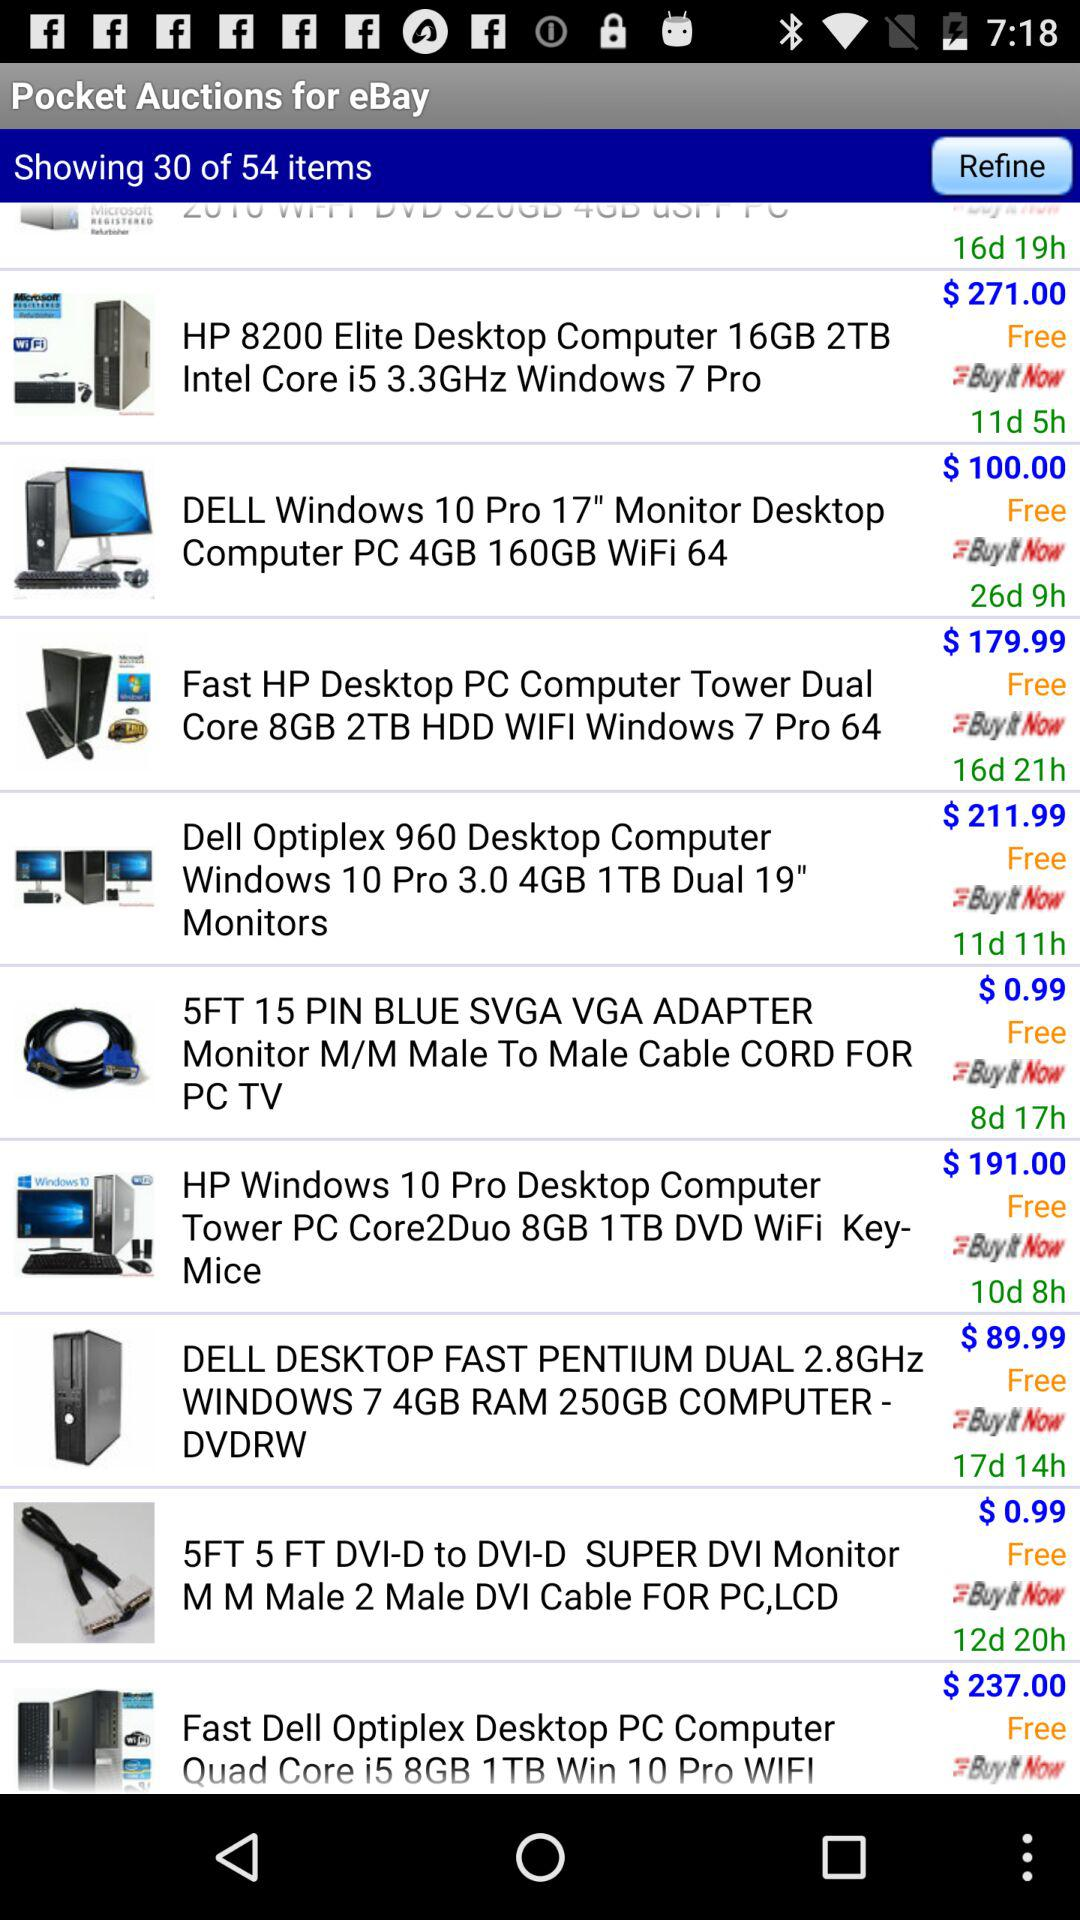How many items in total are there? There are a total of 54 items. 